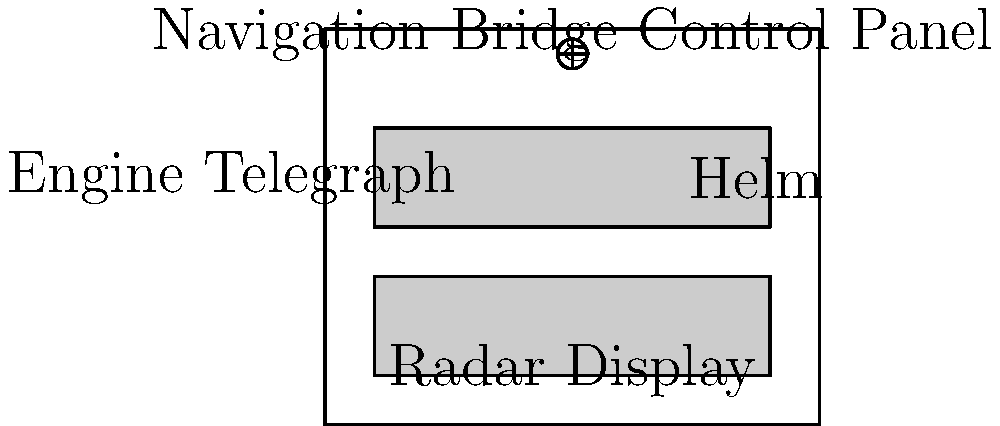In the layout of a typical ocean liner's navigation bridge control panel from the 1930s, which essential component for controlling the ship's speed and direction would most likely be located in the center of the upper control panel? To answer this question, we need to consider the key components of a typical ocean liner's navigation bridge control panel from the 1930s:

1. The navigation bridge control panel usually consists of two main sections: an upper and a lower panel.

2. The upper panel typically contains instruments for navigation and steering, while the lower panel often houses communication devices and additional controls.

3. The most critical components for controlling the ship's speed and direction are:
   a) The engine telegraph: used to communicate speed orders to the engine room
   b) The helm: used to control the ship's rudder and, consequently, its direction

4. In the 1930s, the helm was typically placed in a central, easily accessible position on the bridge to allow for quick and precise steering.

5. The engine telegraph, while also important, was often positioned to one side of the helm.

6. Given the importance of steering for navigation and safety, the helm would likely be placed in the most prominent and central position on the upper control panel.

Therefore, the component most likely to be located in the center of the upper control panel would be the helm, as it was crucial for controlling the ship's direction and required constant attention from the helmsman.
Answer: The helm 